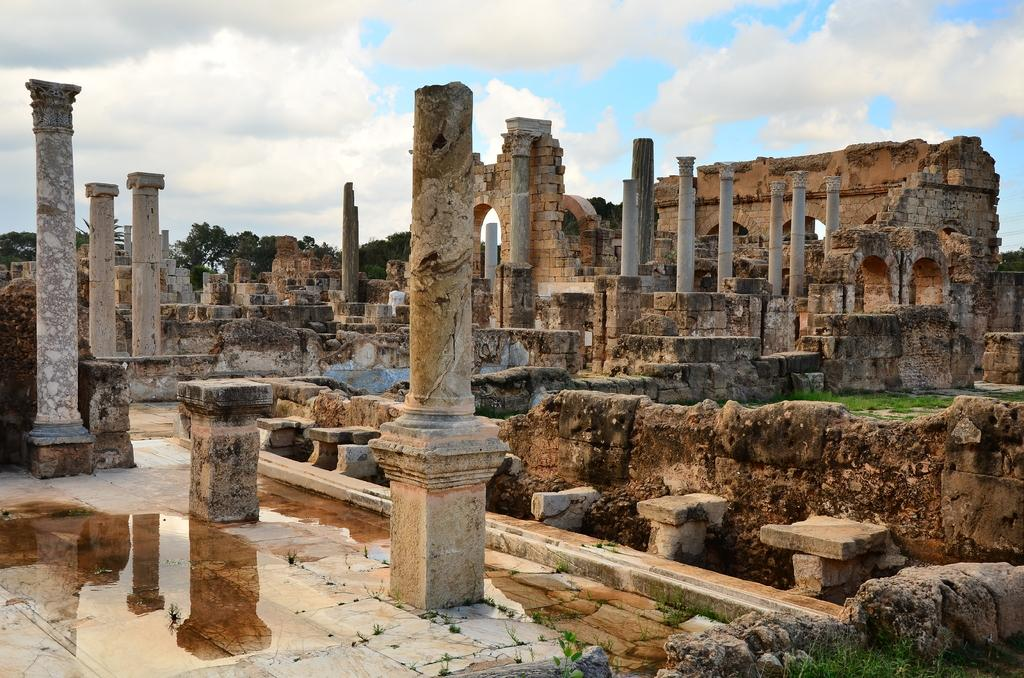What type of structure is in the image? There is a fort in the image. What type of vegetation is visible in the image? There is grass in the image. What can be seen in the background of the image? The sky and trees are visible in the background of the image. What is the condition of the sky in the image? Clouds are present in the sky. What type of jeans is the fort wearing in the image? The fort is not a person and therefore cannot wear jeans. 